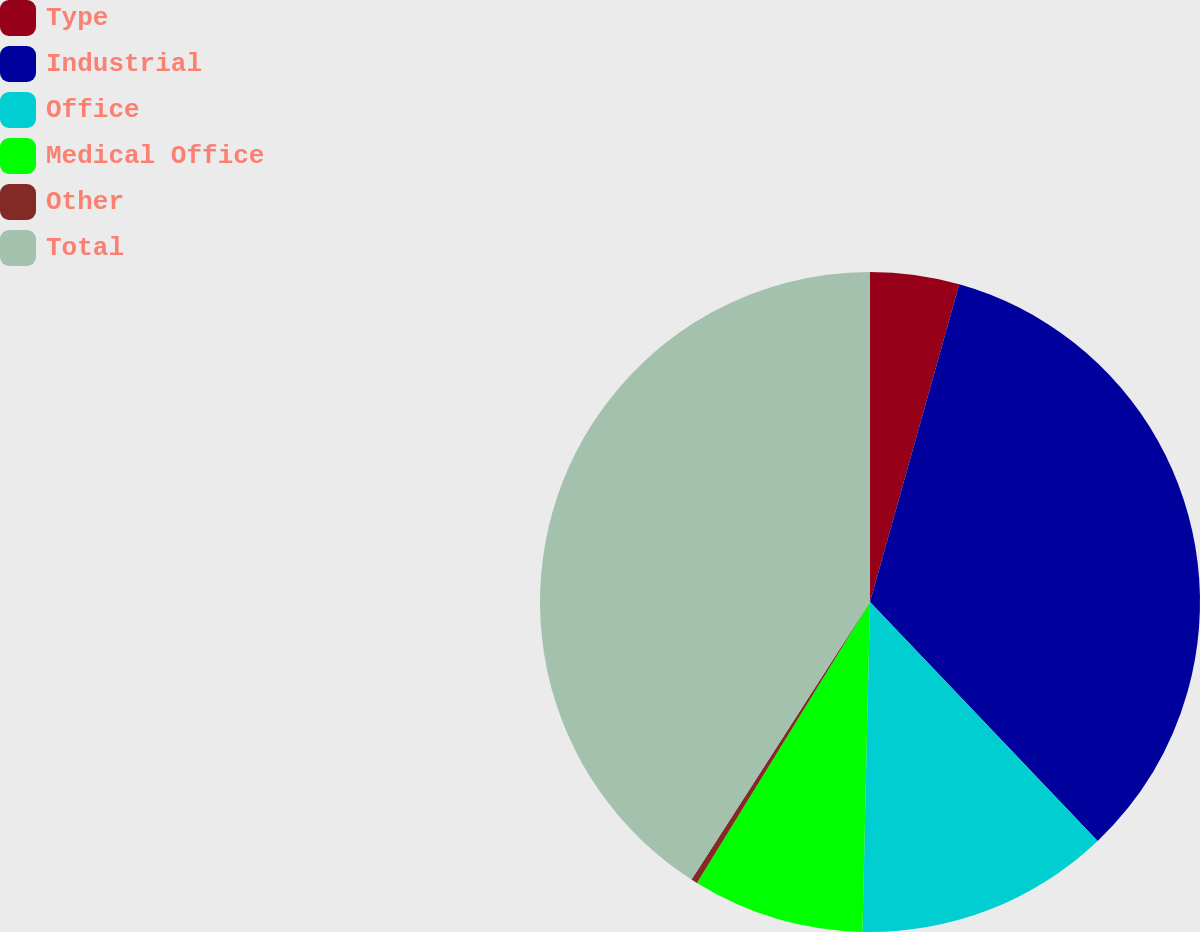Convert chart. <chart><loc_0><loc_0><loc_500><loc_500><pie_chart><fcel>Type<fcel>Industrial<fcel>Office<fcel>Medical Office<fcel>Other<fcel>Total<nl><fcel>4.36%<fcel>33.52%<fcel>12.48%<fcel>8.42%<fcel>0.31%<fcel>40.9%<nl></chart> 